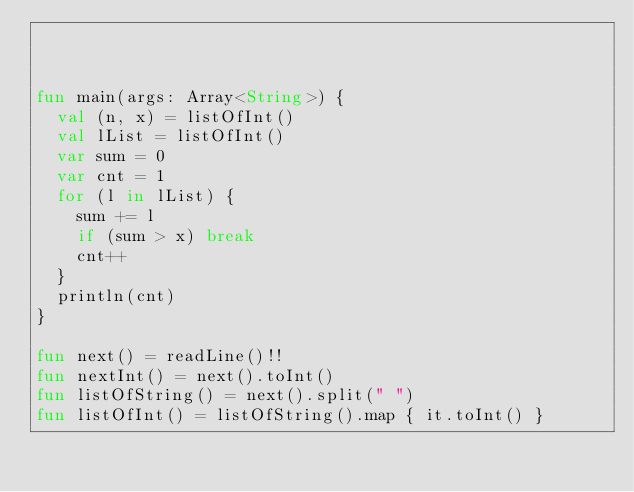<code> <loc_0><loc_0><loc_500><loc_500><_Kotlin_>


fun main(args: Array<String>) {
  val (n, x) = listOfInt()
  val lList = listOfInt()
  var sum = 0
  var cnt = 1
  for (l in lList) {
    sum += l
    if (sum > x) break
    cnt++
  }
  println(cnt)
}

fun next() = readLine()!!
fun nextInt() = next().toInt()
fun listOfString() = next().split(" ")
fun listOfInt() = listOfString().map { it.toInt() }</code> 